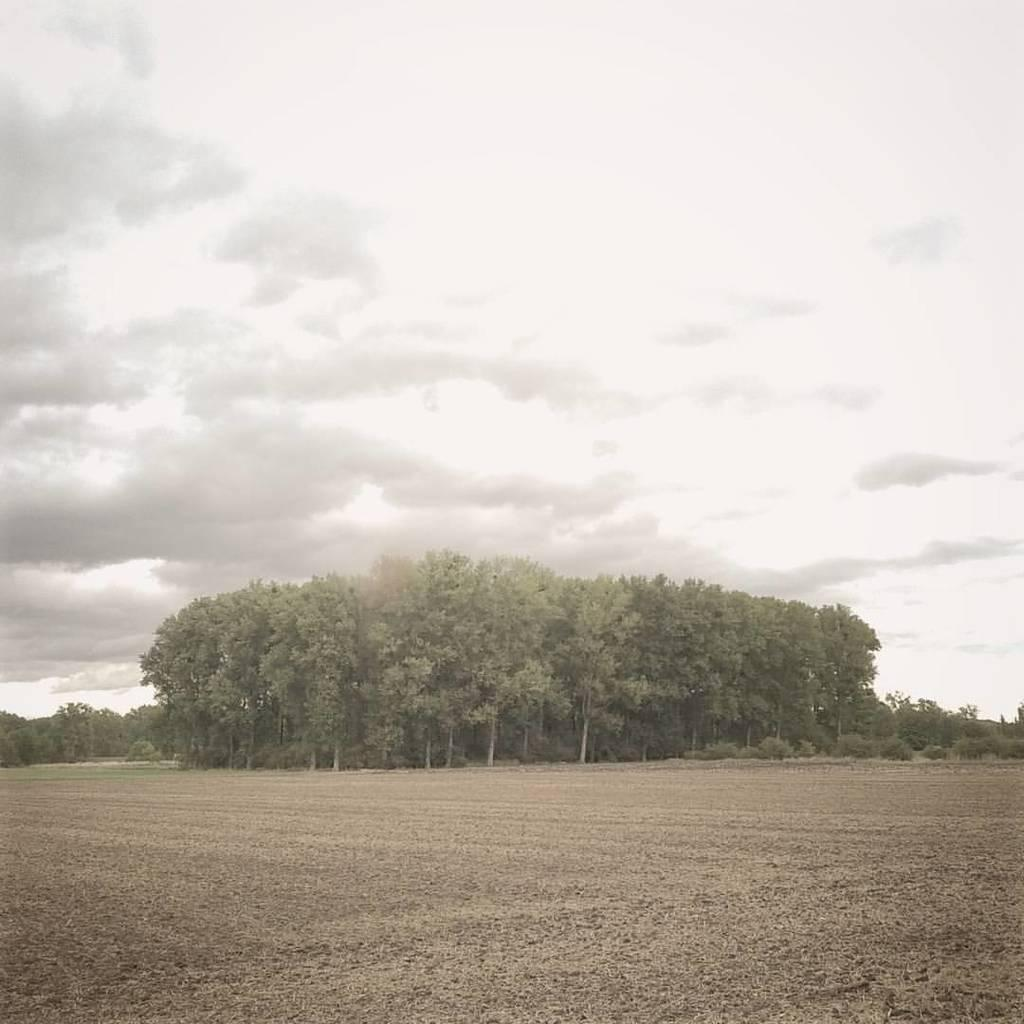What type of vegetation can be seen in the image? There is a group of trees in the image. What is visible in the background of the image? The sky is visible in the background of the image. How would you describe the sky in the image? The sky appears to be cloudy. Can you see any feathers falling from the trees in the image? There are no feathers visible in the image, and no indication that any are falling from the trees. 